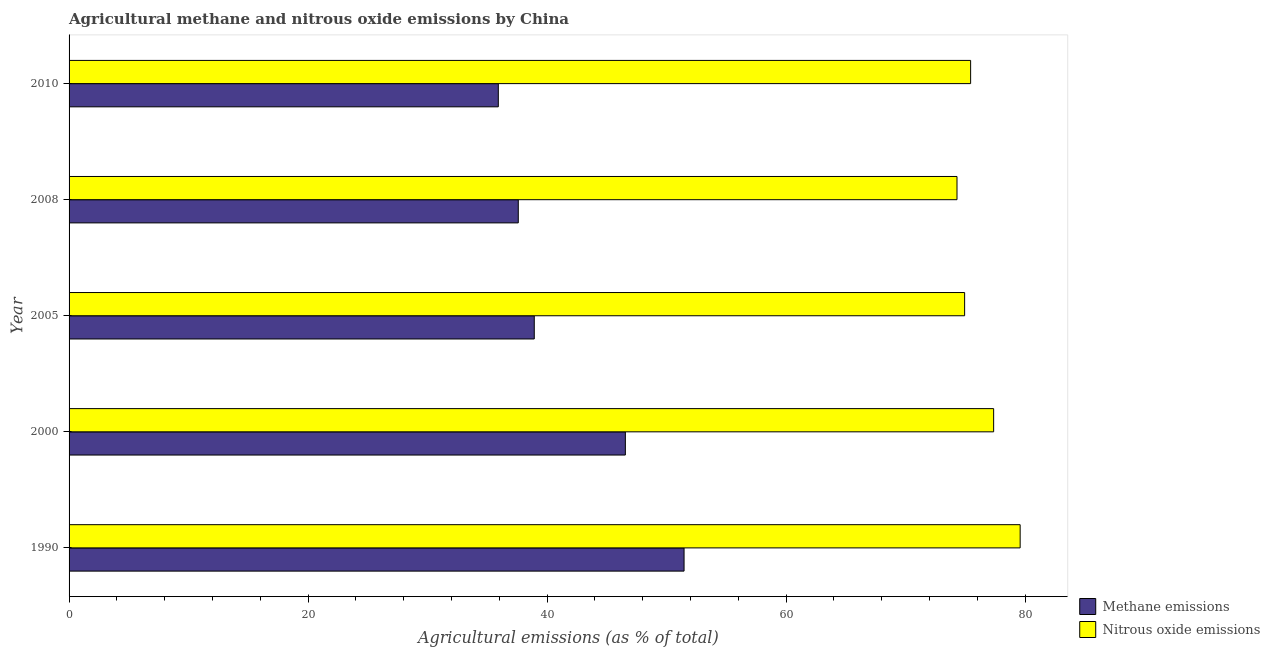How many groups of bars are there?
Your response must be concise. 5. Are the number of bars per tick equal to the number of legend labels?
Give a very brief answer. Yes. Are the number of bars on each tick of the Y-axis equal?
Provide a short and direct response. Yes. What is the label of the 5th group of bars from the top?
Make the answer very short. 1990. What is the amount of methane emissions in 2000?
Your answer should be very brief. 46.55. Across all years, what is the maximum amount of nitrous oxide emissions?
Give a very brief answer. 79.59. Across all years, what is the minimum amount of methane emissions?
Offer a terse response. 35.92. In which year was the amount of nitrous oxide emissions minimum?
Ensure brevity in your answer.  2008. What is the total amount of methane emissions in the graph?
Ensure brevity in your answer.  210.45. What is the difference between the amount of methane emissions in 2000 and that in 2010?
Your answer should be very brief. 10.63. What is the difference between the amount of nitrous oxide emissions in 2000 and the amount of methane emissions in 2010?
Provide a succinct answer. 41.45. What is the average amount of nitrous oxide emissions per year?
Make the answer very short. 76.33. In the year 2005, what is the difference between the amount of nitrous oxide emissions and amount of methane emissions?
Make the answer very short. 36.01. In how many years, is the amount of nitrous oxide emissions greater than 40 %?
Provide a succinct answer. 5. What is the ratio of the amount of methane emissions in 2005 to that in 2008?
Offer a very short reply. 1.04. Is the amount of nitrous oxide emissions in 1990 less than that in 2008?
Your response must be concise. No. What is the difference between the highest and the second highest amount of nitrous oxide emissions?
Provide a succinct answer. 2.22. What is the difference between the highest and the lowest amount of methane emissions?
Your answer should be compact. 15.54. In how many years, is the amount of methane emissions greater than the average amount of methane emissions taken over all years?
Your response must be concise. 2. What does the 1st bar from the top in 1990 represents?
Keep it short and to the point. Nitrous oxide emissions. What does the 2nd bar from the bottom in 2010 represents?
Give a very brief answer. Nitrous oxide emissions. Are all the bars in the graph horizontal?
Your response must be concise. Yes. How many years are there in the graph?
Give a very brief answer. 5. Are the values on the major ticks of X-axis written in scientific E-notation?
Offer a terse response. No. Does the graph contain any zero values?
Make the answer very short. No. Where does the legend appear in the graph?
Provide a succinct answer. Bottom right. How many legend labels are there?
Offer a very short reply. 2. How are the legend labels stacked?
Your answer should be compact. Vertical. What is the title of the graph?
Offer a terse response. Agricultural methane and nitrous oxide emissions by China. What is the label or title of the X-axis?
Your answer should be compact. Agricultural emissions (as % of total). What is the label or title of the Y-axis?
Your answer should be compact. Year. What is the Agricultural emissions (as % of total) in Methane emissions in 1990?
Your answer should be compact. 51.46. What is the Agricultural emissions (as % of total) of Nitrous oxide emissions in 1990?
Offer a very short reply. 79.59. What is the Agricultural emissions (as % of total) of Methane emissions in 2000?
Your response must be concise. 46.55. What is the Agricultural emissions (as % of total) in Nitrous oxide emissions in 2000?
Provide a short and direct response. 77.37. What is the Agricultural emissions (as % of total) in Methane emissions in 2005?
Offer a very short reply. 38.93. What is the Agricultural emissions (as % of total) of Nitrous oxide emissions in 2005?
Keep it short and to the point. 74.94. What is the Agricultural emissions (as % of total) of Methane emissions in 2008?
Make the answer very short. 37.59. What is the Agricultural emissions (as % of total) in Nitrous oxide emissions in 2008?
Give a very brief answer. 74.3. What is the Agricultural emissions (as % of total) in Methane emissions in 2010?
Ensure brevity in your answer.  35.92. What is the Agricultural emissions (as % of total) of Nitrous oxide emissions in 2010?
Give a very brief answer. 75.44. Across all years, what is the maximum Agricultural emissions (as % of total) in Methane emissions?
Provide a short and direct response. 51.46. Across all years, what is the maximum Agricultural emissions (as % of total) in Nitrous oxide emissions?
Ensure brevity in your answer.  79.59. Across all years, what is the minimum Agricultural emissions (as % of total) of Methane emissions?
Provide a succinct answer. 35.92. Across all years, what is the minimum Agricultural emissions (as % of total) in Nitrous oxide emissions?
Your answer should be very brief. 74.3. What is the total Agricultural emissions (as % of total) in Methane emissions in the graph?
Offer a very short reply. 210.44. What is the total Agricultural emissions (as % of total) in Nitrous oxide emissions in the graph?
Provide a succinct answer. 381.63. What is the difference between the Agricultural emissions (as % of total) in Methane emissions in 1990 and that in 2000?
Offer a terse response. 4.91. What is the difference between the Agricultural emissions (as % of total) in Nitrous oxide emissions in 1990 and that in 2000?
Offer a very short reply. 2.22. What is the difference between the Agricultural emissions (as % of total) in Methane emissions in 1990 and that in 2005?
Give a very brief answer. 12.53. What is the difference between the Agricultural emissions (as % of total) of Nitrous oxide emissions in 1990 and that in 2005?
Ensure brevity in your answer.  4.65. What is the difference between the Agricultural emissions (as % of total) of Methane emissions in 1990 and that in 2008?
Your answer should be compact. 13.87. What is the difference between the Agricultural emissions (as % of total) in Nitrous oxide emissions in 1990 and that in 2008?
Keep it short and to the point. 5.29. What is the difference between the Agricultural emissions (as % of total) of Methane emissions in 1990 and that in 2010?
Provide a short and direct response. 15.54. What is the difference between the Agricultural emissions (as % of total) in Nitrous oxide emissions in 1990 and that in 2010?
Provide a succinct answer. 4.14. What is the difference between the Agricultural emissions (as % of total) in Methane emissions in 2000 and that in 2005?
Give a very brief answer. 7.62. What is the difference between the Agricultural emissions (as % of total) of Nitrous oxide emissions in 2000 and that in 2005?
Keep it short and to the point. 2.43. What is the difference between the Agricultural emissions (as % of total) in Methane emissions in 2000 and that in 2008?
Your response must be concise. 8.96. What is the difference between the Agricultural emissions (as % of total) of Nitrous oxide emissions in 2000 and that in 2008?
Provide a succinct answer. 3.07. What is the difference between the Agricultural emissions (as % of total) of Methane emissions in 2000 and that in 2010?
Give a very brief answer. 10.63. What is the difference between the Agricultural emissions (as % of total) of Nitrous oxide emissions in 2000 and that in 2010?
Make the answer very short. 1.93. What is the difference between the Agricultural emissions (as % of total) of Methane emissions in 2005 and that in 2008?
Offer a very short reply. 1.34. What is the difference between the Agricultural emissions (as % of total) in Nitrous oxide emissions in 2005 and that in 2008?
Offer a terse response. 0.64. What is the difference between the Agricultural emissions (as % of total) of Methane emissions in 2005 and that in 2010?
Keep it short and to the point. 3.01. What is the difference between the Agricultural emissions (as % of total) in Nitrous oxide emissions in 2005 and that in 2010?
Ensure brevity in your answer.  -0.5. What is the difference between the Agricultural emissions (as % of total) of Methane emissions in 2008 and that in 2010?
Offer a very short reply. 1.67. What is the difference between the Agricultural emissions (as % of total) in Nitrous oxide emissions in 2008 and that in 2010?
Ensure brevity in your answer.  -1.14. What is the difference between the Agricultural emissions (as % of total) of Methane emissions in 1990 and the Agricultural emissions (as % of total) of Nitrous oxide emissions in 2000?
Your answer should be compact. -25.9. What is the difference between the Agricultural emissions (as % of total) of Methane emissions in 1990 and the Agricultural emissions (as % of total) of Nitrous oxide emissions in 2005?
Offer a very short reply. -23.48. What is the difference between the Agricultural emissions (as % of total) in Methane emissions in 1990 and the Agricultural emissions (as % of total) in Nitrous oxide emissions in 2008?
Offer a terse response. -22.84. What is the difference between the Agricultural emissions (as % of total) in Methane emissions in 1990 and the Agricultural emissions (as % of total) in Nitrous oxide emissions in 2010?
Your answer should be very brief. -23.98. What is the difference between the Agricultural emissions (as % of total) of Methane emissions in 2000 and the Agricultural emissions (as % of total) of Nitrous oxide emissions in 2005?
Offer a terse response. -28.39. What is the difference between the Agricultural emissions (as % of total) of Methane emissions in 2000 and the Agricultural emissions (as % of total) of Nitrous oxide emissions in 2008?
Your response must be concise. -27.75. What is the difference between the Agricultural emissions (as % of total) of Methane emissions in 2000 and the Agricultural emissions (as % of total) of Nitrous oxide emissions in 2010?
Offer a very short reply. -28.89. What is the difference between the Agricultural emissions (as % of total) in Methane emissions in 2005 and the Agricultural emissions (as % of total) in Nitrous oxide emissions in 2008?
Your answer should be very brief. -35.37. What is the difference between the Agricultural emissions (as % of total) in Methane emissions in 2005 and the Agricultural emissions (as % of total) in Nitrous oxide emissions in 2010?
Offer a very short reply. -36.51. What is the difference between the Agricultural emissions (as % of total) of Methane emissions in 2008 and the Agricultural emissions (as % of total) of Nitrous oxide emissions in 2010?
Provide a short and direct response. -37.85. What is the average Agricultural emissions (as % of total) of Methane emissions per year?
Make the answer very short. 42.09. What is the average Agricultural emissions (as % of total) in Nitrous oxide emissions per year?
Give a very brief answer. 76.33. In the year 1990, what is the difference between the Agricultural emissions (as % of total) of Methane emissions and Agricultural emissions (as % of total) of Nitrous oxide emissions?
Give a very brief answer. -28.12. In the year 2000, what is the difference between the Agricultural emissions (as % of total) of Methane emissions and Agricultural emissions (as % of total) of Nitrous oxide emissions?
Your response must be concise. -30.82. In the year 2005, what is the difference between the Agricultural emissions (as % of total) in Methane emissions and Agricultural emissions (as % of total) in Nitrous oxide emissions?
Your response must be concise. -36.01. In the year 2008, what is the difference between the Agricultural emissions (as % of total) in Methane emissions and Agricultural emissions (as % of total) in Nitrous oxide emissions?
Make the answer very short. -36.71. In the year 2010, what is the difference between the Agricultural emissions (as % of total) in Methane emissions and Agricultural emissions (as % of total) in Nitrous oxide emissions?
Offer a very short reply. -39.52. What is the ratio of the Agricultural emissions (as % of total) of Methane emissions in 1990 to that in 2000?
Make the answer very short. 1.11. What is the ratio of the Agricultural emissions (as % of total) in Nitrous oxide emissions in 1990 to that in 2000?
Make the answer very short. 1.03. What is the ratio of the Agricultural emissions (as % of total) in Methane emissions in 1990 to that in 2005?
Ensure brevity in your answer.  1.32. What is the ratio of the Agricultural emissions (as % of total) of Nitrous oxide emissions in 1990 to that in 2005?
Give a very brief answer. 1.06. What is the ratio of the Agricultural emissions (as % of total) of Methane emissions in 1990 to that in 2008?
Your answer should be very brief. 1.37. What is the ratio of the Agricultural emissions (as % of total) of Nitrous oxide emissions in 1990 to that in 2008?
Offer a very short reply. 1.07. What is the ratio of the Agricultural emissions (as % of total) in Methane emissions in 1990 to that in 2010?
Offer a terse response. 1.43. What is the ratio of the Agricultural emissions (as % of total) in Nitrous oxide emissions in 1990 to that in 2010?
Ensure brevity in your answer.  1.05. What is the ratio of the Agricultural emissions (as % of total) of Methane emissions in 2000 to that in 2005?
Your response must be concise. 1.2. What is the ratio of the Agricultural emissions (as % of total) in Nitrous oxide emissions in 2000 to that in 2005?
Your response must be concise. 1.03. What is the ratio of the Agricultural emissions (as % of total) in Methane emissions in 2000 to that in 2008?
Your answer should be very brief. 1.24. What is the ratio of the Agricultural emissions (as % of total) in Nitrous oxide emissions in 2000 to that in 2008?
Your response must be concise. 1.04. What is the ratio of the Agricultural emissions (as % of total) in Methane emissions in 2000 to that in 2010?
Your answer should be very brief. 1.3. What is the ratio of the Agricultural emissions (as % of total) of Nitrous oxide emissions in 2000 to that in 2010?
Ensure brevity in your answer.  1.03. What is the ratio of the Agricultural emissions (as % of total) in Methane emissions in 2005 to that in 2008?
Your response must be concise. 1.04. What is the ratio of the Agricultural emissions (as % of total) in Nitrous oxide emissions in 2005 to that in 2008?
Provide a short and direct response. 1.01. What is the ratio of the Agricultural emissions (as % of total) in Methane emissions in 2005 to that in 2010?
Your response must be concise. 1.08. What is the ratio of the Agricultural emissions (as % of total) in Nitrous oxide emissions in 2005 to that in 2010?
Your answer should be compact. 0.99. What is the ratio of the Agricultural emissions (as % of total) in Methane emissions in 2008 to that in 2010?
Provide a succinct answer. 1.05. What is the ratio of the Agricultural emissions (as % of total) of Nitrous oxide emissions in 2008 to that in 2010?
Give a very brief answer. 0.98. What is the difference between the highest and the second highest Agricultural emissions (as % of total) of Methane emissions?
Offer a very short reply. 4.91. What is the difference between the highest and the second highest Agricultural emissions (as % of total) in Nitrous oxide emissions?
Your answer should be very brief. 2.22. What is the difference between the highest and the lowest Agricultural emissions (as % of total) in Methane emissions?
Provide a succinct answer. 15.54. What is the difference between the highest and the lowest Agricultural emissions (as % of total) of Nitrous oxide emissions?
Make the answer very short. 5.29. 